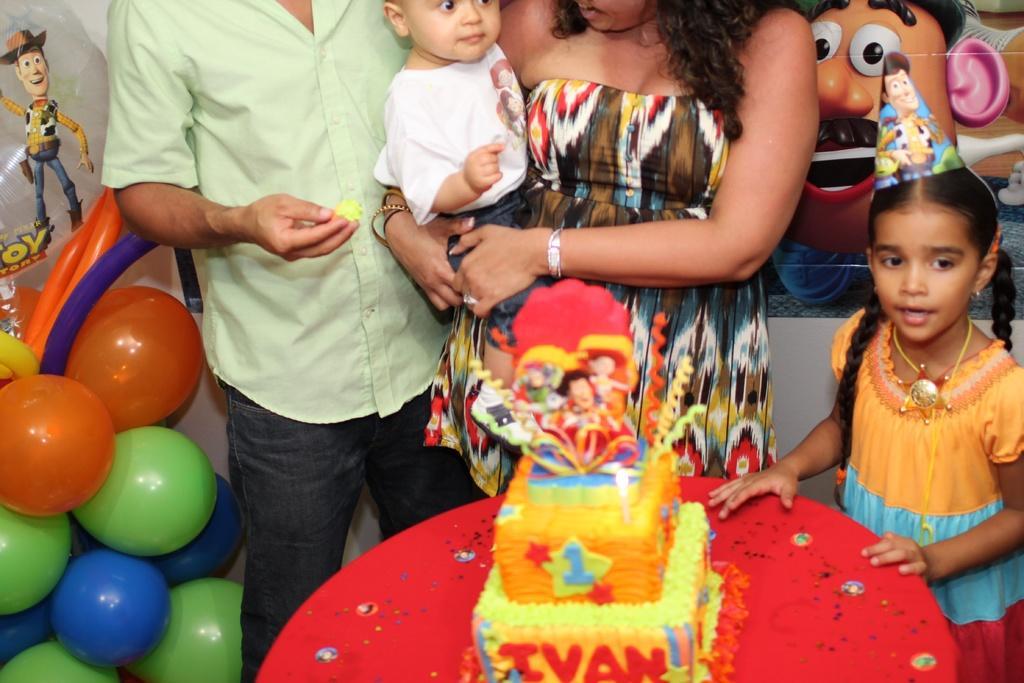Can you describe this image briefly? In this image there is a woman in the middle who is holding the boy. Beside the woman there is a man who is holding the cake. In front of them there is a table on which there is a cake. On the cake there are toys. On the right side there is a girl who is standing on the floor by wearing the cap. In the background there are poster. On the left side bottom there are balloons. 